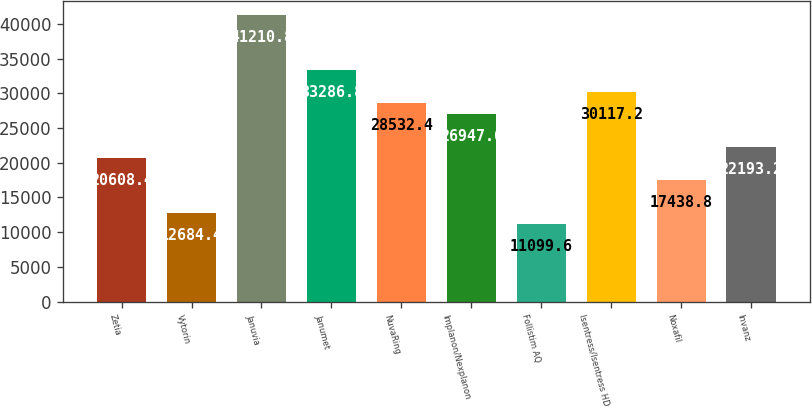Convert chart. <chart><loc_0><loc_0><loc_500><loc_500><bar_chart><fcel>Zetia<fcel>Vytorin<fcel>Januvia<fcel>Janumet<fcel>NuvaRing<fcel>Implanon/Nexplanon<fcel>Follistim AQ<fcel>Isentress/Isentress HD<fcel>Noxafil<fcel>Invanz<nl><fcel>20608.4<fcel>12684.4<fcel>41210.8<fcel>33286.8<fcel>28532.4<fcel>26947.6<fcel>11099.6<fcel>30117.2<fcel>17438.8<fcel>22193.2<nl></chart> 